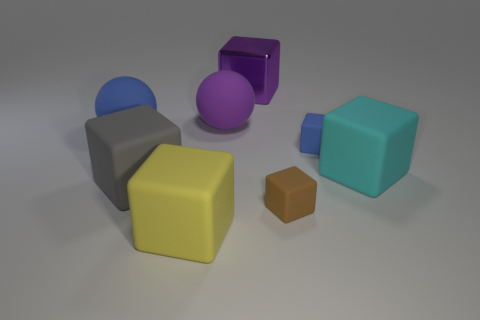Subtract all rubber cubes. How many cubes are left? 1 Subtract all brown blocks. How many blocks are left? 5 Add 2 yellow rubber objects. How many objects exist? 10 Subtract all brown blocks. Subtract all red balls. How many blocks are left? 5 Subtract all tiny yellow metallic things. Subtract all spheres. How many objects are left? 6 Add 6 gray blocks. How many gray blocks are left? 7 Add 3 large metallic cubes. How many large metallic cubes exist? 4 Subtract 1 blue cubes. How many objects are left? 7 Subtract all blocks. How many objects are left? 2 